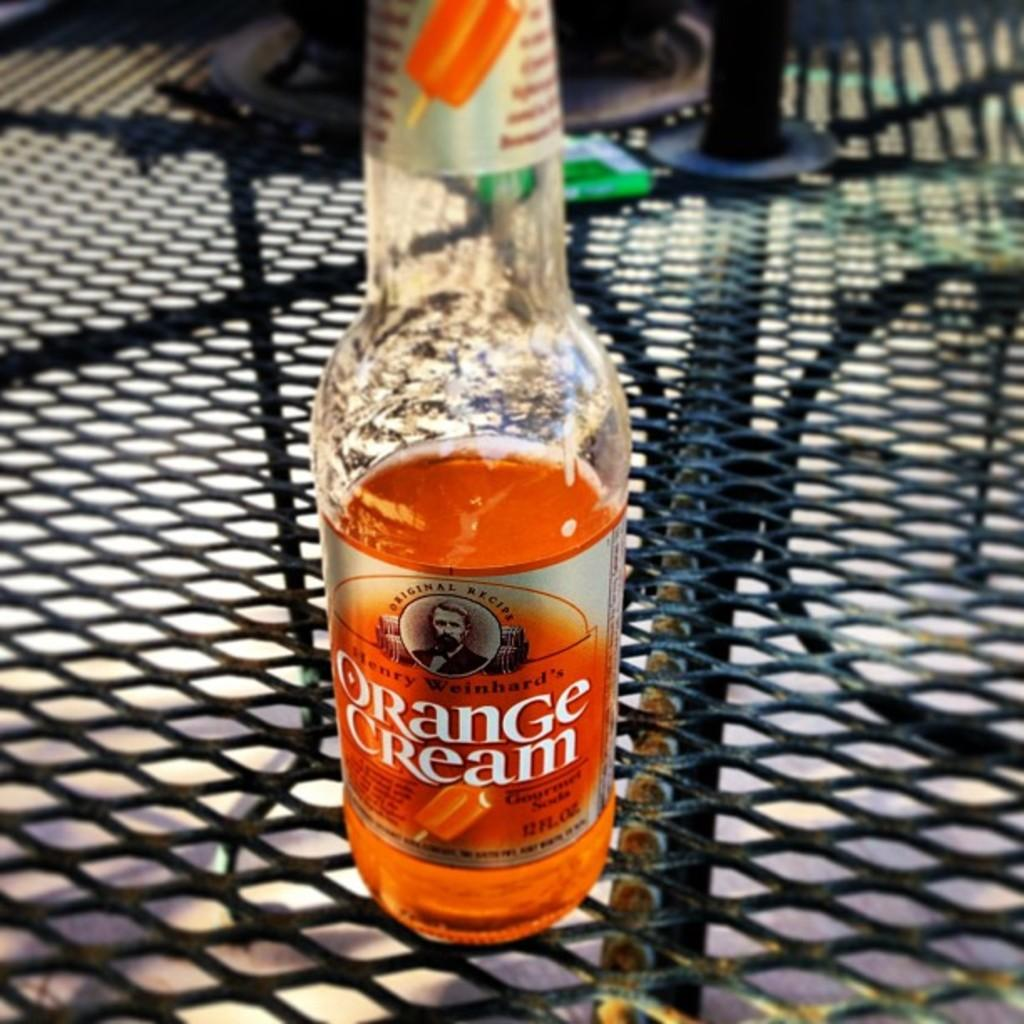What object is present in the image that contains a liquid? There is a bottle in the image that contains an orange liquid. Who or what is depicted on the bottle? A person's image is visible on the bottle. Where is the bottle located in the image? The bottle is placed on a grill. What type of development is taking place in the hall in the image? There is no hall or development present in the image; it features a bottle with an orange liquid and a person's image on it, placed on a grill. Can you see any ants crawling on the bottle in the image? There are no ants visible in the image. 